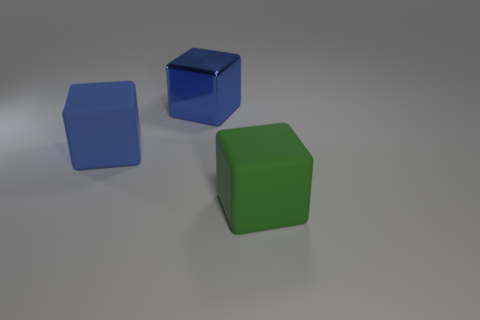Do the matte block to the left of the green rubber thing and the metal block have the same size?
Offer a terse response. Yes. Is the number of large green metallic cubes greater than the number of big shiny cubes?
Your answer should be very brief. No. What number of big objects are blocks or green objects?
Your response must be concise. 3. What number of other large green blocks are the same material as the big green cube?
Ensure brevity in your answer.  0. Is the color of the large matte thing in front of the blue matte thing the same as the shiny thing?
Keep it short and to the point. No. How many brown things are spheres or rubber things?
Offer a terse response. 0. Is there any other thing that is the same material as the green cube?
Offer a terse response. Yes. Does the big blue block on the left side of the large blue metal thing have the same material as the green thing?
Your answer should be very brief. Yes. How many things are either rubber things or blue things in front of the big blue shiny object?
Provide a succinct answer. 2. There is a large object that is behind the big matte object that is to the left of the big green matte cube; what number of metal blocks are left of it?
Make the answer very short. 0. 